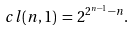<formula> <loc_0><loc_0><loc_500><loc_500>c l ( n , 1 ) \, = \, 2 ^ { 2 ^ { n - 1 } - n } .</formula> 